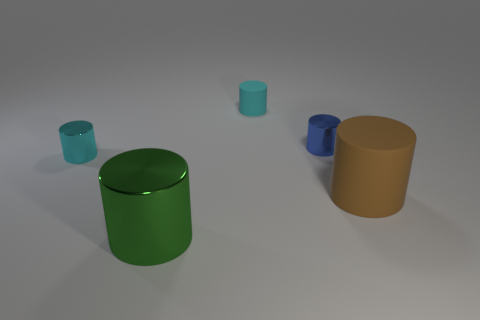Can you tell me the material of the green cylinder in the center? The green cylinder appears to have a reflective surface, suggesting it could be made of a polished metal or a similarly shiny plastic. 